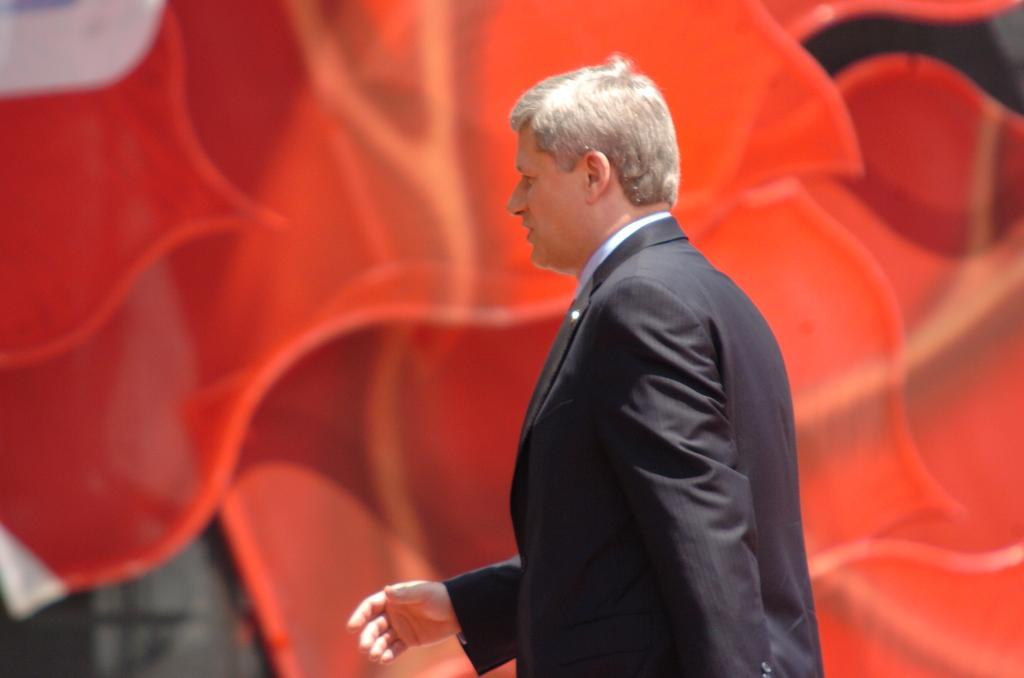Describe this image in one or two sentences. In this picture we can see a man in the black blazer is stood on the path and behind the man there is an orange item. 